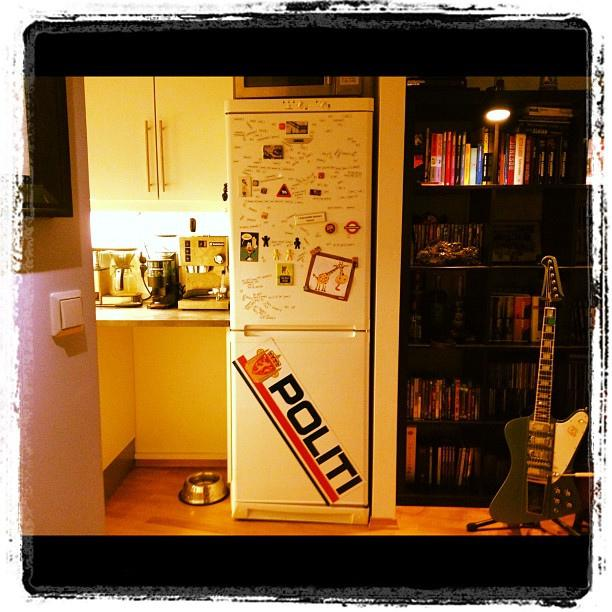In what nation is this apartment likely to be situated? italy 